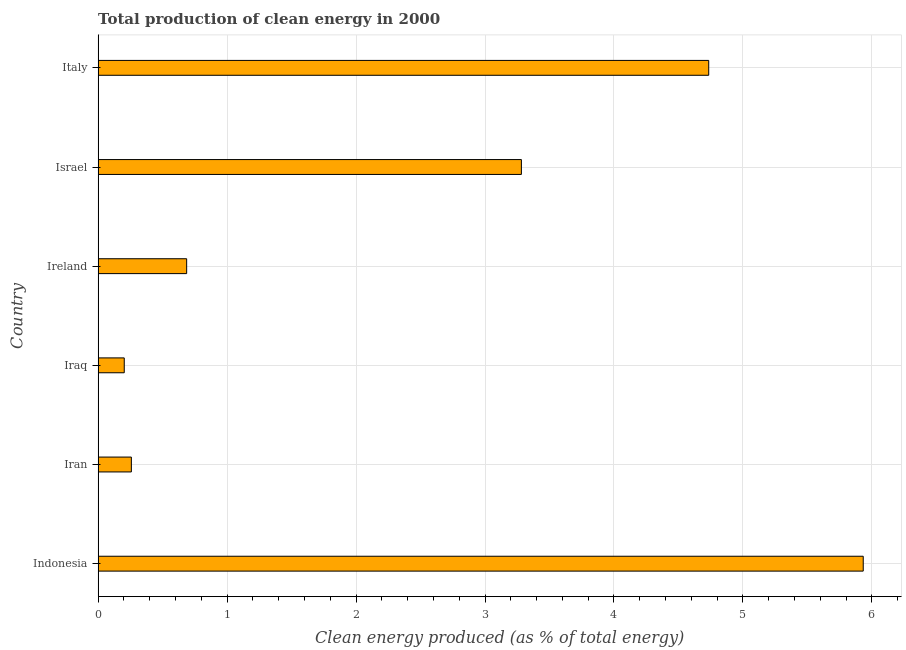Does the graph contain any zero values?
Provide a short and direct response. No. Does the graph contain grids?
Make the answer very short. Yes. What is the title of the graph?
Provide a short and direct response. Total production of clean energy in 2000. What is the label or title of the X-axis?
Ensure brevity in your answer.  Clean energy produced (as % of total energy). What is the label or title of the Y-axis?
Provide a succinct answer. Country. What is the production of clean energy in Indonesia?
Provide a short and direct response. 5.93. Across all countries, what is the maximum production of clean energy?
Your answer should be compact. 5.93. Across all countries, what is the minimum production of clean energy?
Provide a succinct answer. 0.2. In which country was the production of clean energy maximum?
Keep it short and to the point. Indonesia. In which country was the production of clean energy minimum?
Provide a succinct answer. Iraq. What is the sum of the production of clean energy?
Your response must be concise. 15.1. What is the difference between the production of clean energy in Iraq and Ireland?
Keep it short and to the point. -0.48. What is the average production of clean energy per country?
Offer a terse response. 2.52. What is the median production of clean energy?
Give a very brief answer. 1.98. What is the ratio of the production of clean energy in Ireland to that in Italy?
Your answer should be compact. 0.14. What is the difference between the highest and the second highest production of clean energy?
Ensure brevity in your answer.  1.2. Is the sum of the production of clean energy in Ireland and Italy greater than the maximum production of clean energy across all countries?
Offer a very short reply. No. What is the difference between the highest and the lowest production of clean energy?
Provide a short and direct response. 5.73. Are all the bars in the graph horizontal?
Ensure brevity in your answer.  Yes. What is the difference between two consecutive major ticks on the X-axis?
Make the answer very short. 1. Are the values on the major ticks of X-axis written in scientific E-notation?
Ensure brevity in your answer.  No. What is the Clean energy produced (as % of total energy) of Indonesia?
Keep it short and to the point. 5.93. What is the Clean energy produced (as % of total energy) of Iran?
Offer a terse response. 0.26. What is the Clean energy produced (as % of total energy) of Iraq?
Offer a terse response. 0.2. What is the Clean energy produced (as % of total energy) in Ireland?
Offer a terse response. 0.69. What is the Clean energy produced (as % of total energy) in Israel?
Ensure brevity in your answer.  3.28. What is the Clean energy produced (as % of total energy) in Italy?
Ensure brevity in your answer.  4.73. What is the difference between the Clean energy produced (as % of total energy) in Indonesia and Iran?
Ensure brevity in your answer.  5.67. What is the difference between the Clean energy produced (as % of total energy) in Indonesia and Iraq?
Make the answer very short. 5.73. What is the difference between the Clean energy produced (as % of total energy) in Indonesia and Ireland?
Offer a terse response. 5.25. What is the difference between the Clean energy produced (as % of total energy) in Indonesia and Israel?
Offer a terse response. 2.65. What is the difference between the Clean energy produced (as % of total energy) in Indonesia and Italy?
Provide a succinct answer. 1.2. What is the difference between the Clean energy produced (as % of total energy) in Iran and Iraq?
Give a very brief answer. 0.06. What is the difference between the Clean energy produced (as % of total energy) in Iran and Ireland?
Make the answer very short. -0.43. What is the difference between the Clean energy produced (as % of total energy) in Iran and Israel?
Keep it short and to the point. -3.02. What is the difference between the Clean energy produced (as % of total energy) in Iran and Italy?
Offer a terse response. -4.48. What is the difference between the Clean energy produced (as % of total energy) in Iraq and Ireland?
Your answer should be very brief. -0.48. What is the difference between the Clean energy produced (as % of total energy) in Iraq and Israel?
Your response must be concise. -3.08. What is the difference between the Clean energy produced (as % of total energy) in Iraq and Italy?
Your response must be concise. -4.53. What is the difference between the Clean energy produced (as % of total energy) in Ireland and Israel?
Make the answer very short. -2.6. What is the difference between the Clean energy produced (as % of total energy) in Ireland and Italy?
Your answer should be compact. -4.05. What is the difference between the Clean energy produced (as % of total energy) in Israel and Italy?
Make the answer very short. -1.45. What is the ratio of the Clean energy produced (as % of total energy) in Indonesia to that in Iran?
Give a very brief answer. 23.02. What is the ratio of the Clean energy produced (as % of total energy) in Indonesia to that in Iraq?
Keep it short and to the point. 29.28. What is the ratio of the Clean energy produced (as % of total energy) in Indonesia to that in Ireland?
Make the answer very short. 8.64. What is the ratio of the Clean energy produced (as % of total energy) in Indonesia to that in Israel?
Your response must be concise. 1.81. What is the ratio of the Clean energy produced (as % of total energy) in Indonesia to that in Italy?
Provide a short and direct response. 1.25. What is the ratio of the Clean energy produced (as % of total energy) in Iran to that in Iraq?
Provide a short and direct response. 1.27. What is the ratio of the Clean energy produced (as % of total energy) in Iran to that in Ireland?
Make the answer very short. 0.38. What is the ratio of the Clean energy produced (as % of total energy) in Iran to that in Israel?
Ensure brevity in your answer.  0.08. What is the ratio of the Clean energy produced (as % of total energy) in Iran to that in Italy?
Offer a very short reply. 0.05. What is the ratio of the Clean energy produced (as % of total energy) in Iraq to that in Ireland?
Offer a terse response. 0.29. What is the ratio of the Clean energy produced (as % of total energy) in Iraq to that in Israel?
Offer a very short reply. 0.06. What is the ratio of the Clean energy produced (as % of total energy) in Iraq to that in Italy?
Your response must be concise. 0.04. What is the ratio of the Clean energy produced (as % of total energy) in Ireland to that in Israel?
Keep it short and to the point. 0.21. What is the ratio of the Clean energy produced (as % of total energy) in Ireland to that in Italy?
Make the answer very short. 0.14. What is the ratio of the Clean energy produced (as % of total energy) in Israel to that in Italy?
Your response must be concise. 0.69. 